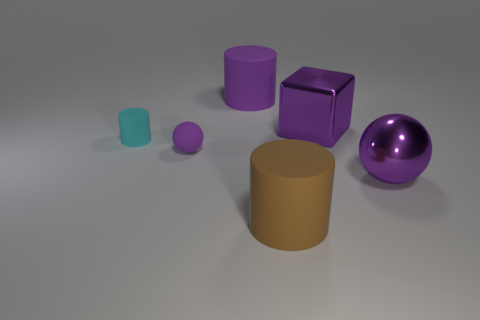There is a matte cylinder that is the same color as the large sphere; what is its size?
Offer a very short reply. Large. What is the large object that is both on the left side of the large ball and in front of the tiny purple matte ball made of?
Give a very brief answer. Rubber. Is there a big object in front of the big matte object that is to the left of the brown matte cylinder on the right side of the tiny rubber sphere?
Provide a succinct answer. Yes. The tiny purple object that is made of the same material as the tiny cyan cylinder is what shape?
Offer a terse response. Sphere. Is the number of tiny purple things on the left side of the cyan rubber cylinder less than the number of purple metallic objects behind the tiny purple matte thing?
Provide a short and direct response. Yes. How many tiny objects are cubes or purple balls?
Make the answer very short. 1. Do the purple matte thing left of the large purple rubber cylinder and the big metal object in front of the big purple cube have the same shape?
Your answer should be very brief. Yes. What size is the shiny thing that is in front of the big purple metallic cube that is right of the purple matte object behind the purple matte ball?
Offer a terse response. Large. What size is the object that is in front of the large purple ball?
Your response must be concise. Large. What material is the ball on the right side of the large purple matte cylinder?
Provide a short and direct response. Metal. 